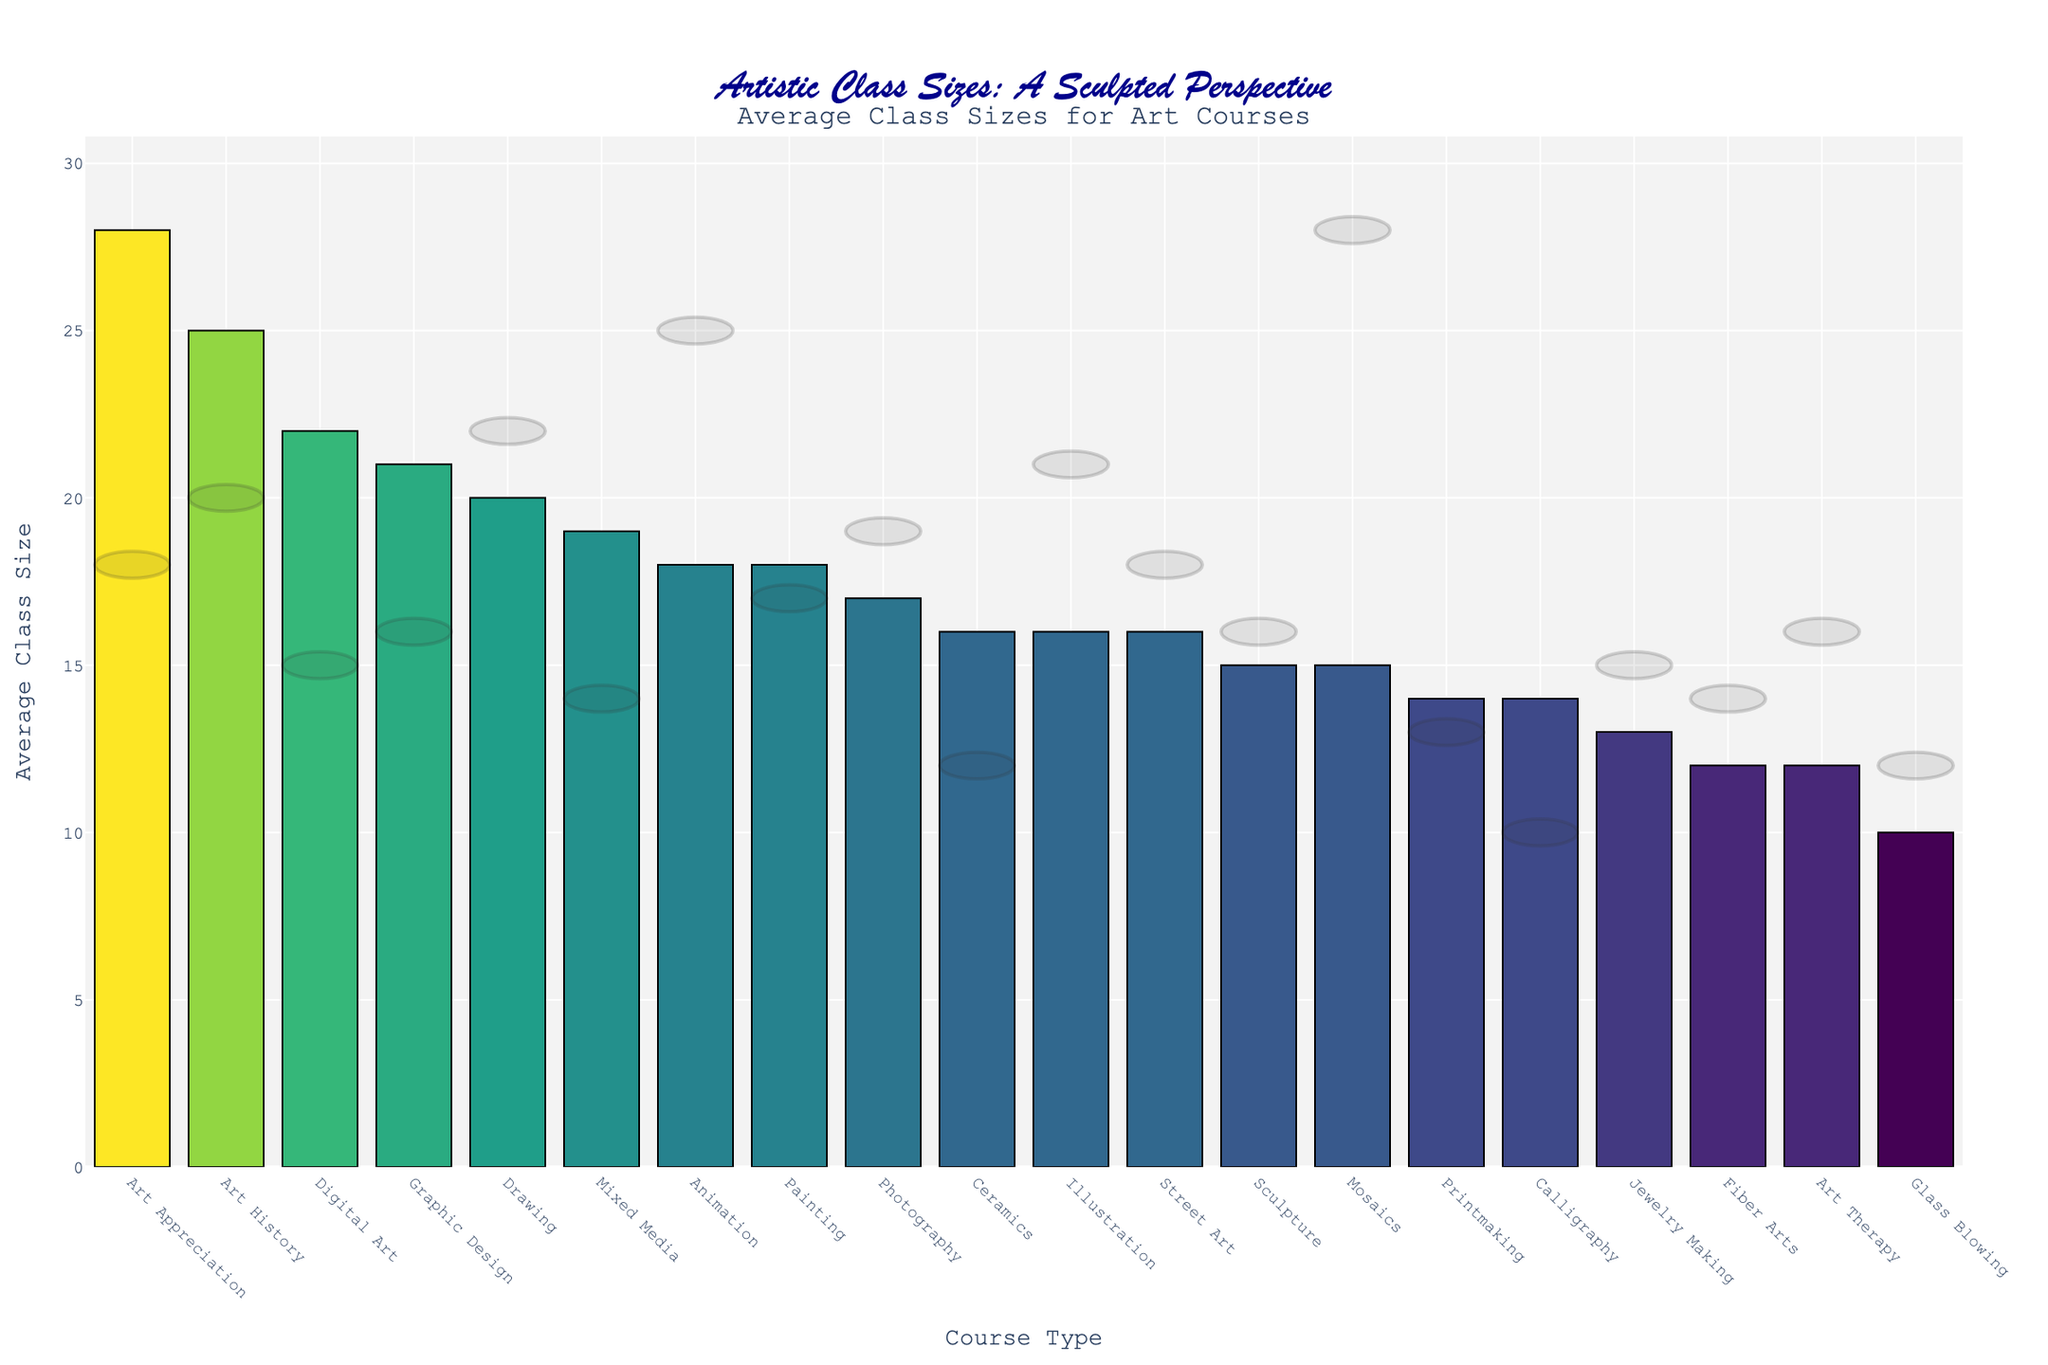What is the average class size for the course with the largest class size? The figure shows Art Appreciation has an average class size of 28, which is the highest among all course types.
Answer: 28 Which course has the smallest average class size? Glass Blowing has the smallest average class size, easily identified as its bar is the shortest among all courses.
Answer: Glass Blowing Compare the average class size of Painting and Drawing. Which one is larger and by how much? Drawing has an average class size of 20, while Painting has 18. The difference is 20 - 18 = 2.
Answer: Drawing by 2 What is the combined average class size of Ceramics, Illustration, and Street Art courses? Ceramics has 16, Illustration has 16, and Street Art has 16 average class sizes. Summing these: 16 + 16 + 16 = 48.
Answer: 48 Which courses have an average class size larger than 20? Courses with bars taller than the y-axis value of 20 are Digital Art, Art History, Graphic Design, and Art Appreciation.
Answer: Digital Art, Art History, Graphic Design, Art Appreciation What is the difference in average class sizes between Fiber Arts and Mixed Media? Fiber Arts has an average class size of 12, and Mixed Media has 19. The difference is 19 - 12 = 7.
Answer: 7 What's the range of the average class sizes in the figure? The highest average class size is for Art Appreciation (28), and the lowest for Glass Blowing (10). The range is 28 - 10 = 18.
Answer: 18 What is the average class size for Animation, and how does it compare visually to Jewelry Making? Animation has 18, and Jewelry Making has 13. Animation's bar is visually taller by 5 units than Jewelry Making's.
Answer: Animation is taller by 5 units Which type of art course has an average class size closest to the median value of all the courses? The median can be determined by arranging average sizes in order: 10, 12, 12, 13, 14, 14, 15, 15, 16, 16, 16, 17, 18, 18, 19, 20, 21, 22, 25, 28. The middle values are 16 and 16, so median is (16+16)/2 = 16. Courses closest to this are Ceramics, Illustration, and Street Art.
Answer: Ceramics, Illustration, Street Art How many courses have average class sizes less than 15? Visually identify courses with bars shorter than the y-axis value of 15: Printmaking, Jewelry Making, Glass Blowing, Fiber Arts, Calligraphy, and Art Therapy.
Answer: 6 